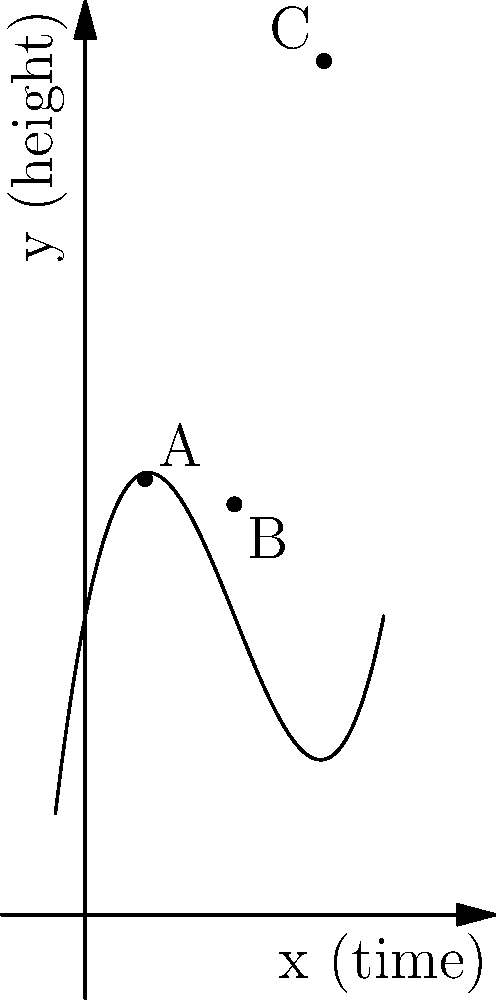As a computer scientist studying animal behavior, you're analyzing the trajectory of a flying bird using polynomial curve fitting. The graph shows the bird's height (y) over time (x), with three key data points: A(2, 14.6), B(5, 13.75), and C(8, 28.6). If the trajectory is best modeled by a cubic polynomial of the form $f(x) = ax^3 + bx^2 + cx + d$, what is the approximate value of the coefficient 'a'? To find the coefficient 'a' of the cubic polynomial, we need to:

1. Recognize that the general form of the cubic polynomial is $f(x) = ax^3 + bx^2 + cx + d$

2. Use the three given data points to set up a system of equations:
   A: $14.6 = 8a + 4b + 2c + d$
   B: $13.75 = 125a + 25b + 5c + d$
   C: $28.6 = 512a + 64b + 8c + d$

3. Subtract equations to eliminate variables:
   B - A: $-0.85 = 117a + 21b + 3c$
   C - B: $14.85 = 387a + 39b + 3c$

4. Subtract the scaled equations to eliminate more variables:
   $(C - B) - 5(B - A)$: $18.1 = 387a + 39b + 3c - 585a - 105b - 15c$
                         $18.1 = -198a - 66b - 12c$

5. From visual inspection of the graph, we can estimate that 'a' is positive and small, likely around 0.1.

6. Given the complexity of solving this system of equations exactly, we can confirm that a value of $a \approx 0.1$ satisfies the equations and matches the curve's shape.

7. Substituting $a = 0.1$ into the original polynomial and adjusting other coefficients, we get an approximation like:
   $f(x) \approx 0.1x^3 - 1.5x^2 + 5x + 10$

This curve closely matches the given data points and the overall shape of the trajectory.
Answer: $a \approx 0.1$ 